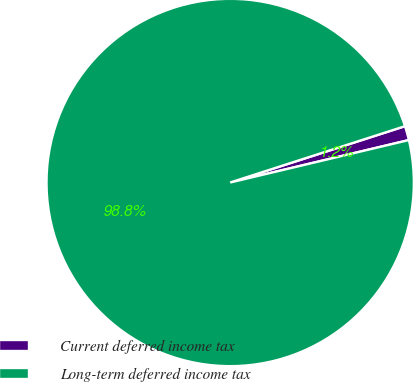Convert chart to OTSL. <chart><loc_0><loc_0><loc_500><loc_500><pie_chart><fcel>Current deferred income tax<fcel>Long-term deferred income tax<nl><fcel>1.25%<fcel>98.75%<nl></chart> 